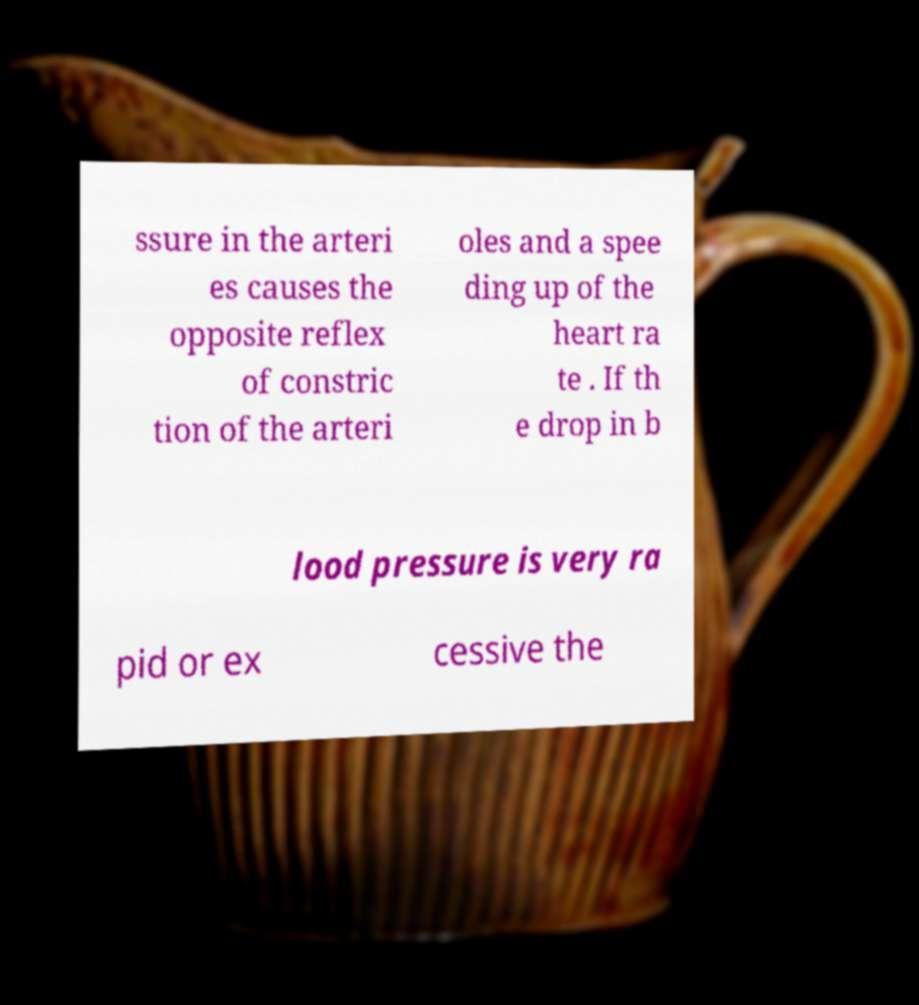Could you extract and type out the text from this image? ssure in the arteri es causes the opposite reflex of constric tion of the arteri oles and a spee ding up of the heart ra te . If th e drop in b lood pressure is very ra pid or ex cessive the 